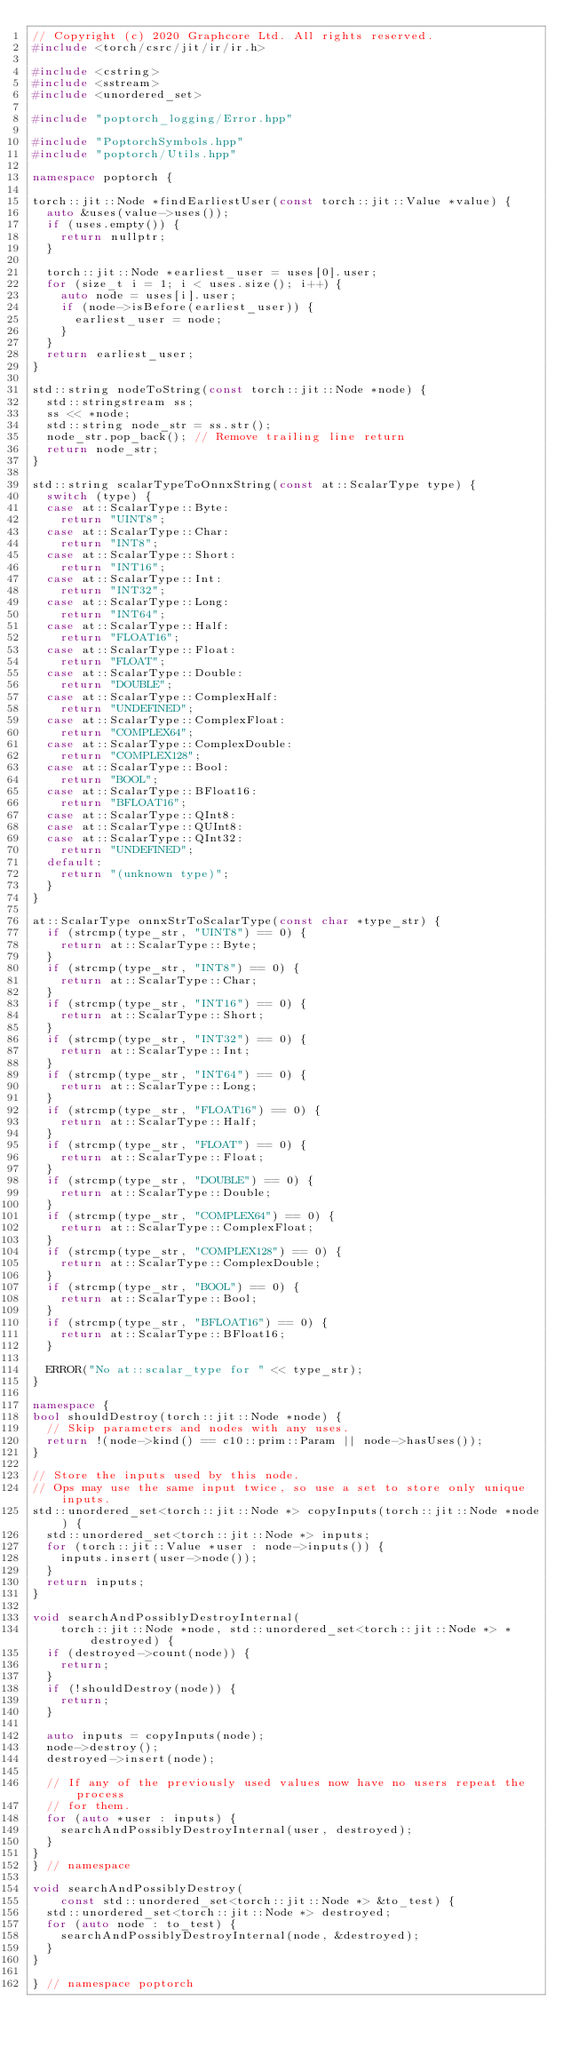Convert code to text. <code><loc_0><loc_0><loc_500><loc_500><_C++_>// Copyright (c) 2020 Graphcore Ltd. All rights reserved.
#include <torch/csrc/jit/ir/ir.h>

#include <cstring>
#include <sstream>
#include <unordered_set>

#include "poptorch_logging/Error.hpp"

#include "PoptorchSymbols.hpp"
#include "poptorch/Utils.hpp"

namespace poptorch {

torch::jit::Node *findEarliestUser(const torch::jit::Value *value) {
  auto &uses(value->uses());
  if (uses.empty()) {
    return nullptr;
  }

  torch::jit::Node *earliest_user = uses[0].user;
  for (size_t i = 1; i < uses.size(); i++) {
    auto node = uses[i].user;
    if (node->isBefore(earliest_user)) {
      earliest_user = node;
    }
  }
  return earliest_user;
}

std::string nodeToString(const torch::jit::Node *node) {
  std::stringstream ss;
  ss << *node;
  std::string node_str = ss.str();
  node_str.pop_back(); // Remove trailing line return
  return node_str;
}

std::string scalarTypeToOnnxString(const at::ScalarType type) {
  switch (type) {
  case at::ScalarType::Byte:
    return "UINT8";
  case at::ScalarType::Char:
    return "INT8";
  case at::ScalarType::Short:
    return "INT16";
  case at::ScalarType::Int:
    return "INT32";
  case at::ScalarType::Long:
    return "INT64";
  case at::ScalarType::Half:
    return "FLOAT16";
  case at::ScalarType::Float:
    return "FLOAT";
  case at::ScalarType::Double:
    return "DOUBLE";
  case at::ScalarType::ComplexHalf:
    return "UNDEFINED";
  case at::ScalarType::ComplexFloat:
    return "COMPLEX64";
  case at::ScalarType::ComplexDouble:
    return "COMPLEX128";
  case at::ScalarType::Bool:
    return "BOOL";
  case at::ScalarType::BFloat16:
    return "BFLOAT16";
  case at::ScalarType::QInt8:
  case at::ScalarType::QUInt8:
  case at::ScalarType::QInt32:
    return "UNDEFINED";
  default:
    return "(unknown type)";
  }
}

at::ScalarType onnxStrToScalarType(const char *type_str) {
  if (strcmp(type_str, "UINT8") == 0) {
    return at::ScalarType::Byte;
  }
  if (strcmp(type_str, "INT8") == 0) {
    return at::ScalarType::Char;
  }
  if (strcmp(type_str, "INT16") == 0) {
    return at::ScalarType::Short;
  }
  if (strcmp(type_str, "INT32") == 0) {
    return at::ScalarType::Int;
  }
  if (strcmp(type_str, "INT64") == 0) {
    return at::ScalarType::Long;
  }
  if (strcmp(type_str, "FLOAT16") == 0) {
    return at::ScalarType::Half;
  }
  if (strcmp(type_str, "FLOAT") == 0) {
    return at::ScalarType::Float;
  }
  if (strcmp(type_str, "DOUBLE") == 0) {
    return at::ScalarType::Double;
  }
  if (strcmp(type_str, "COMPLEX64") == 0) {
    return at::ScalarType::ComplexFloat;
  }
  if (strcmp(type_str, "COMPLEX128") == 0) {
    return at::ScalarType::ComplexDouble;
  }
  if (strcmp(type_str, "BOOL") == 0) {
    return at::ScalarType::Bool;
  }
  if (strcmp(type_str, "BFLOAT16") == 0) {
    return at::ScalarType::BFloat16;
  }

  ERROR("No at::scalar_type for " << type_str);
}

namespace {
bool shouldDestroy(torch::jit::Node *node) {
  // Skip parameters and nodes with any uses.
  return !(node->kind() == c10::prim::Param || node->hasUses());
}

// Store the inputs used by this node.
// Ops may use the same input twice, so use a set to store only unique inputs.
std::unordered_set<torch::jit::Node *> copyInputs(torch::jit::Node *node) {
  std::unordered_set<torch::jit::Node *> inputs;
  for (torch::jit::Value *user : node->inputs()) {
    inputs.insert(user->node());
  }
  return inputs;
}

void searchAndPossiblyDestroyInternal(
    torch::jit::Node *node, std::unordered_set<torch::jit::Node *> *destroyed) {
  if (destroyed->count(node)) {
    return;
  }
  if (!shouldDestroy(node)) {
    return;
  }

  auto inputs = copyInputs(node);
  node->destroy();
  destroyed->insert(node);

  // If any of the previously used values now have no users repeat the process
  // for them.
  for (auto *user : inputs) {
    searchAndPossiblyDestroyInternal(user, destroyed);
  }
}
} // namespace

void searchAndPossiblyDestroy(
    const std::unordered_set<torch::jit::Node *> &to_test) {
  std::unordered_set<torch::jit::Node *> destroyed;
  for (auto node : to_test) {
    searchAndPossiblyDestroyInternal(node, &destroyed);
  }
}

} // namespace poptorch
</code> 